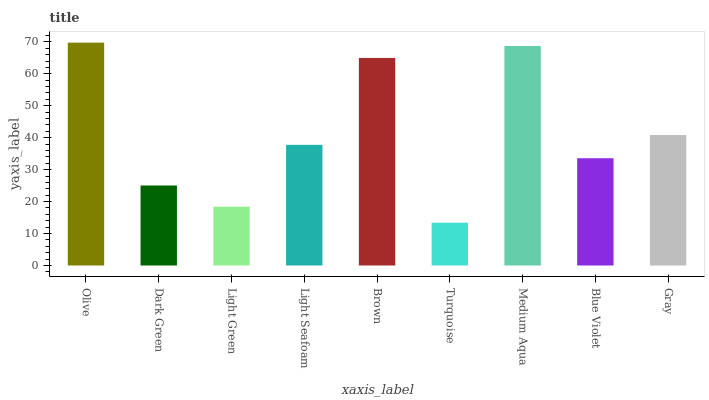Is Turquoise the minimum?
Answer yes or no. Yes. Is Olive the maximum?
Answer yes or no. Yes. Is Dark Green the minimum?
Answer yes or no. No. Is Dark Green the maximum?
Answer yes or no. No. Is Olive greater than Dark Green?
Answer yes or no. Yes. Is Dark Green less than Olive?
Answer yes or no. Yes. Is Dark Green greater than Olive?
Answer yes or no. No. Is Olive less than Dark Green?
Answer yes or no. No. Is Light Seafoam the high median?
Answer yes or no. Yes. Is Light Seafoam the low median?
Answer yes or no. Yes. Is Gray the high median?
Answer yes or no. No. Is Gray the low median?
Answer yes or no. No. 